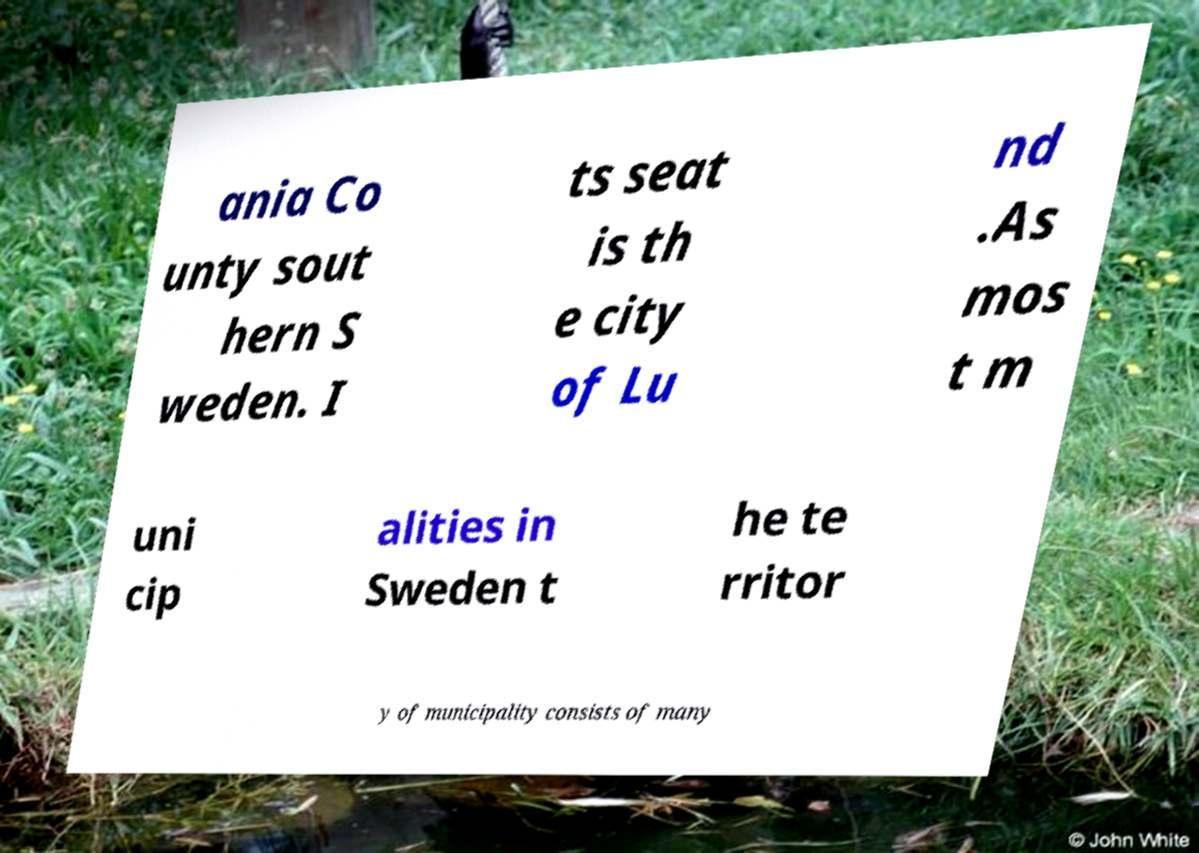Can you accurately transcribe the text from the provided image for me? ania Co unty sout hern S weden. I ts seat is th e city of Lu nd .As mos t m uni cip alities in Sweden t he te rritor y of municipality consists of many 